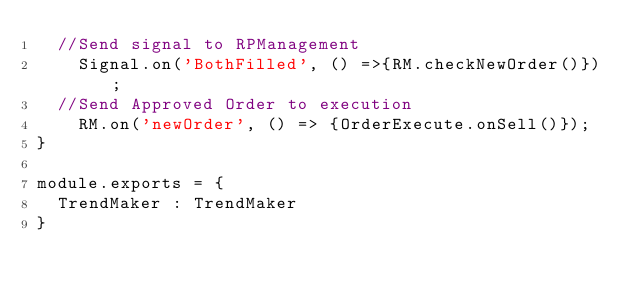<code> <loc_0><loc_0><loc_500><loc_500><_JavaScript_>	//Send signal to RPManagement
    Signal.on('BothFilled', () =>{RM.checkNewOrder()});
	//Send Approved Order to execution
    RM.on('newOrder', () => {OrderExecute.onSell()});
}

module.exports = {
	TrendMaker : TrendMaker
}
</code> 